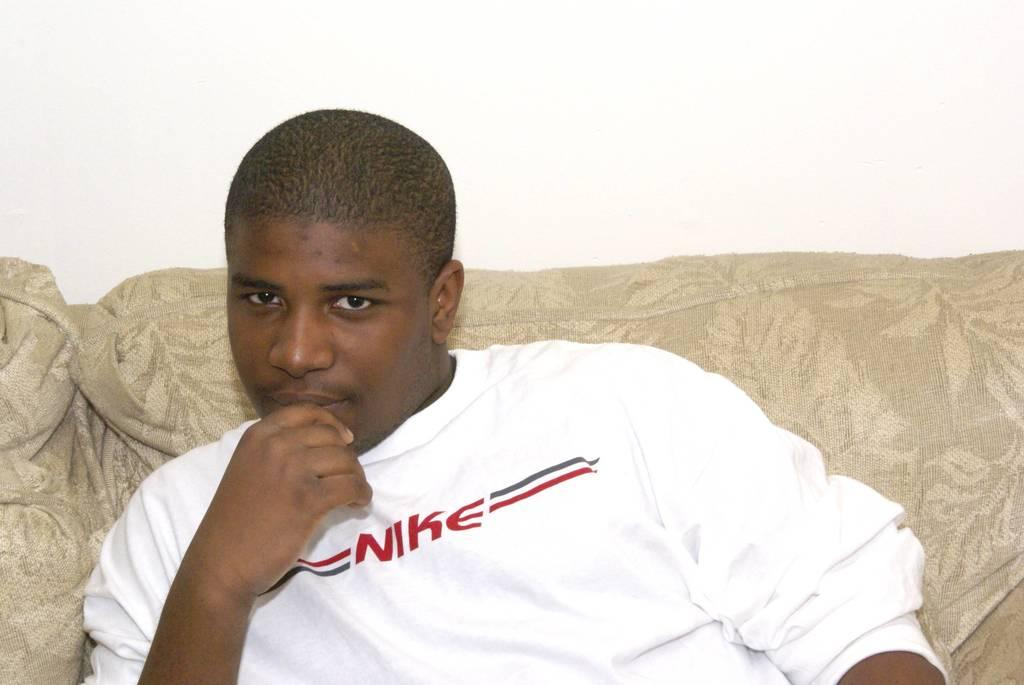<image>
Summarize the visual content of the image. A young black man sitting on a couch with a white Nike shirt on. 